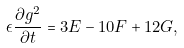Convert formula to latex. <formula><loc_0><loc_0><loc_500><loc_500>\epsilon \frac { \partial g ^ { 2 } } { \partial t } = 3 E - 1 0 F + 1 2 G ,</formula> 